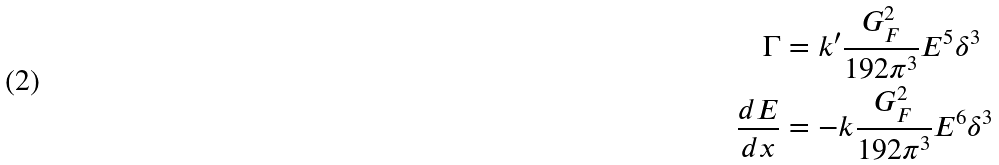Convert formula to latex. <formula><loc_0><loc_0><loc_500><loc_500>\Gamma & = k ^ { \prime } \frac { G _ { F } ^ { 2 } } { 1 9 2 \pi ^ { 3 } } E ^ { 5 } \delta ^ { 3 } \\ \frac { d E } { d x } & = - k \frac { G _ { F } ^ { 2 } } { 1 9 2 \pi ^ { 3 } } E ^ { 6 } \delta ^ { 3 }</formula> 